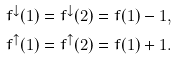Convert formula to latex. <formula><loc_0><loc_0><loc_500><loc_500>f ^ { \downarrow } ( 1 ) = f ^ { \downarrow } ( 2 ) = f ( 1 ) - 1 , \\ f ^ { \uparrow } ( 1 ) = f ^ { \uparrow } ( 2 ) = f ( 1 ) + 1 .</formula> 